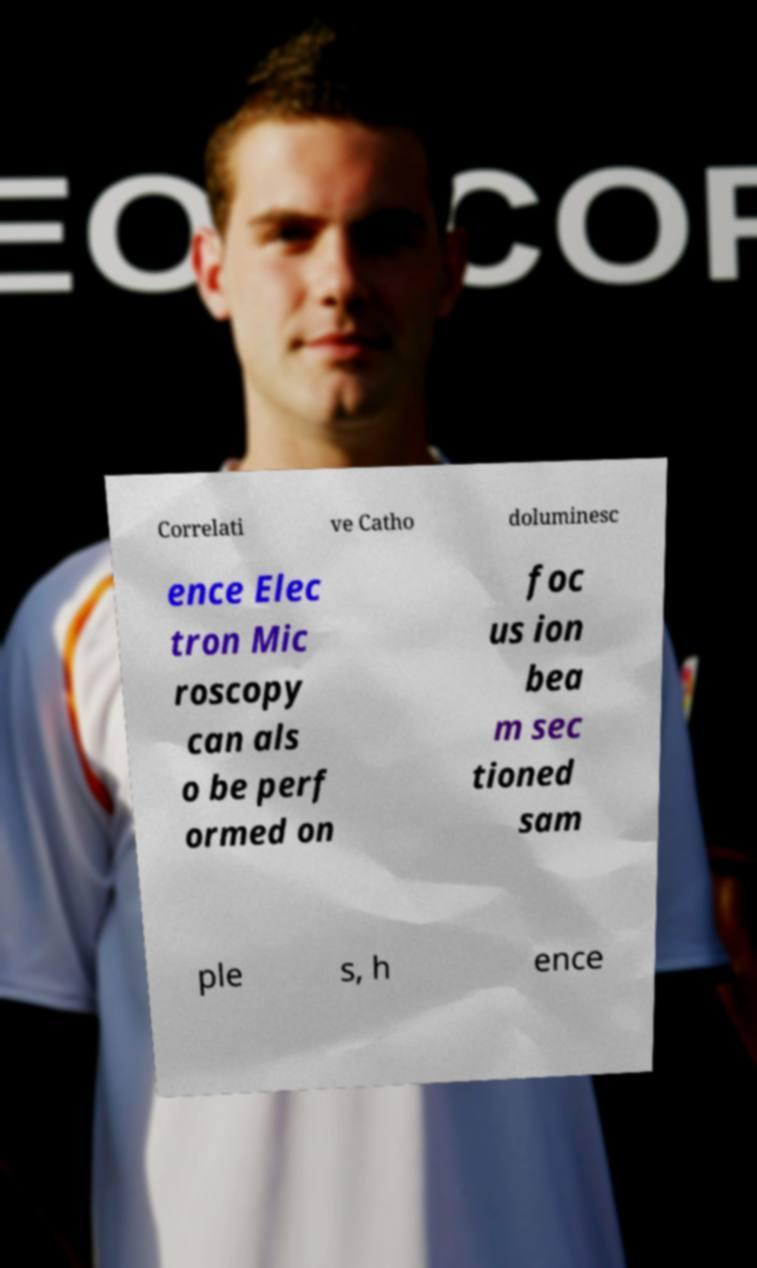What messages or text are displayed in this image? I need them in a readable, typed format. Correlati ve Catho doluminesc ence Elec tron Mic roscopy can als o be perf ormed on foc us ion bea m sec tioned sam ple s, h ence 